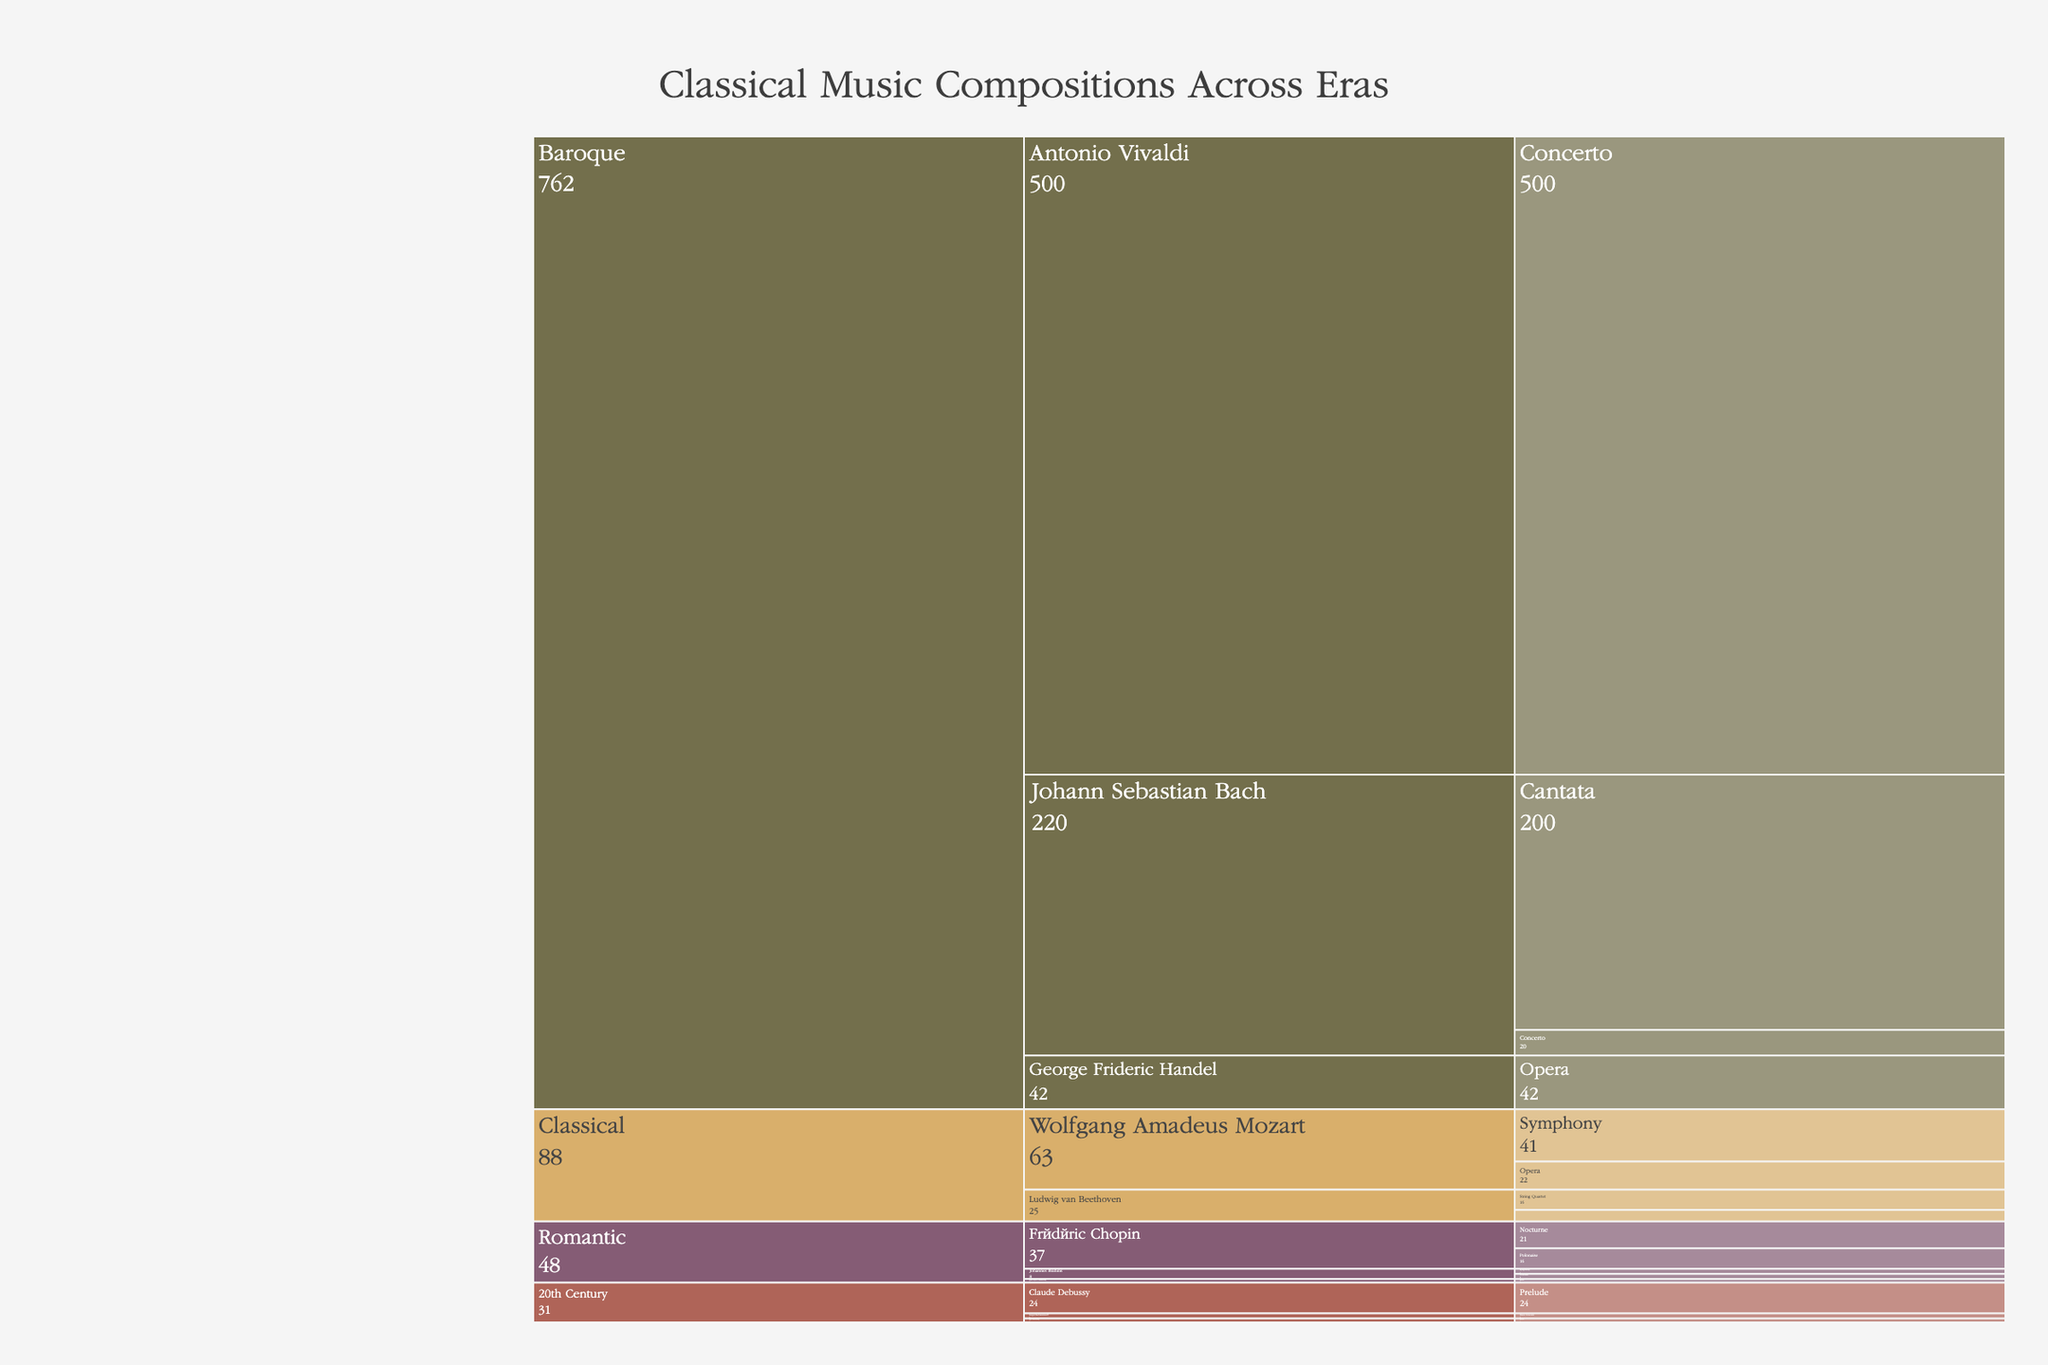How many compositions were created by Johann Sebastian Bach in total? To find the total number of compositions by Johann Sebastian Bach, sum the counts of Cantatas and Concertos: 200 (Cantata) + 20 (Concerto)
Answer: 220 Which composer has the highest number of compositions, and what is that number? The composer with the highest number of compositions is Antonio Vivaldi, with a total of 500 compositions (Concerto)
Answer: Antonio Vivaldi, 500 How does the number of Beethoven's Symphonies compare with Mozart's Symphonies? Beethoven composed 9 Symphonies, while Mozart composed 41 Symphonies. Comparing the two, Mozart's number is greater: 41 > 9
Answer: Mozart's are greater What is the combined number of Operas composed by Mozart and Handel? Adding the number of Operas by Mozart (22) and Handel (42) gives a total of 22 + 42 = 64
Answer: 64 What is the overall total number of compositions in the figure? Sum all the compositions across all eras and genres:
200 + 20 + 42 + 500 + 41 + 22 + 9 + 16 + 21 + 16 + 3 + 4 + 4 + 3 + 24 + 4 = 929
Answer: 929 How many genres did Frédéric Chopin compose in and what were they? In the chart, Frédéric Chopin composed in two genres: Nocturne and Polonaise.
Answer: Two, Nocturne and Polonaise 